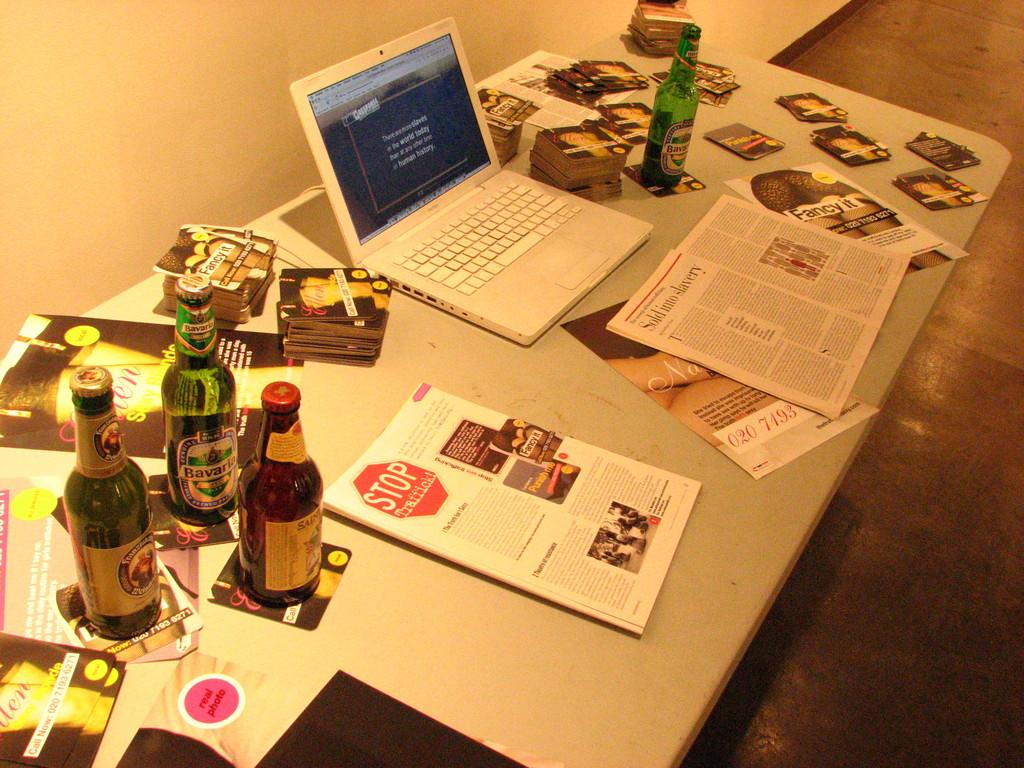What electronic device is on the table in the image? There is a laptop on the table. What else can be seen on the table besides the laptop? There are papers and a book on the table. Is there any beverage container on the table? Yes, there is a bottle on the table. What type of sticks are being used for the discussion in the image? There is no discussion or sticks present in the image; it only features a laptop, papers, a book, and a bottle on the table. 